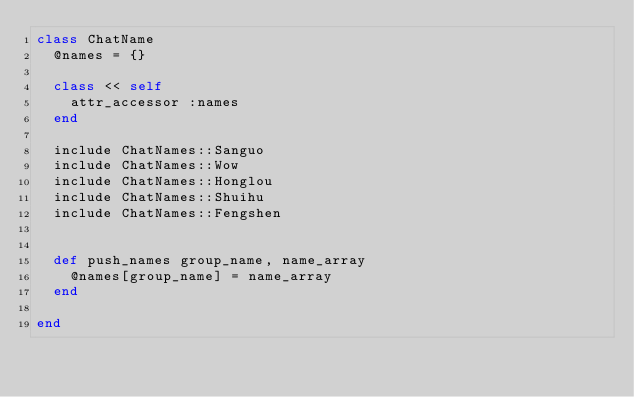<code> <loc_0><loc_0><loc_500><loc_500><_Ruby_>class ChatName
  @names = {}

  class << self
    attr_accessor :names
  end

  include ChatNames::Sanguo
  include ChatNames::Wow
  include ChatNames::Honglou
  include ChatNames::Shuihu
  include ChatNames::Fengshen
  

  def push_names group_name, name_array
    @names[group_name] = name_array
  end

end
</code> 